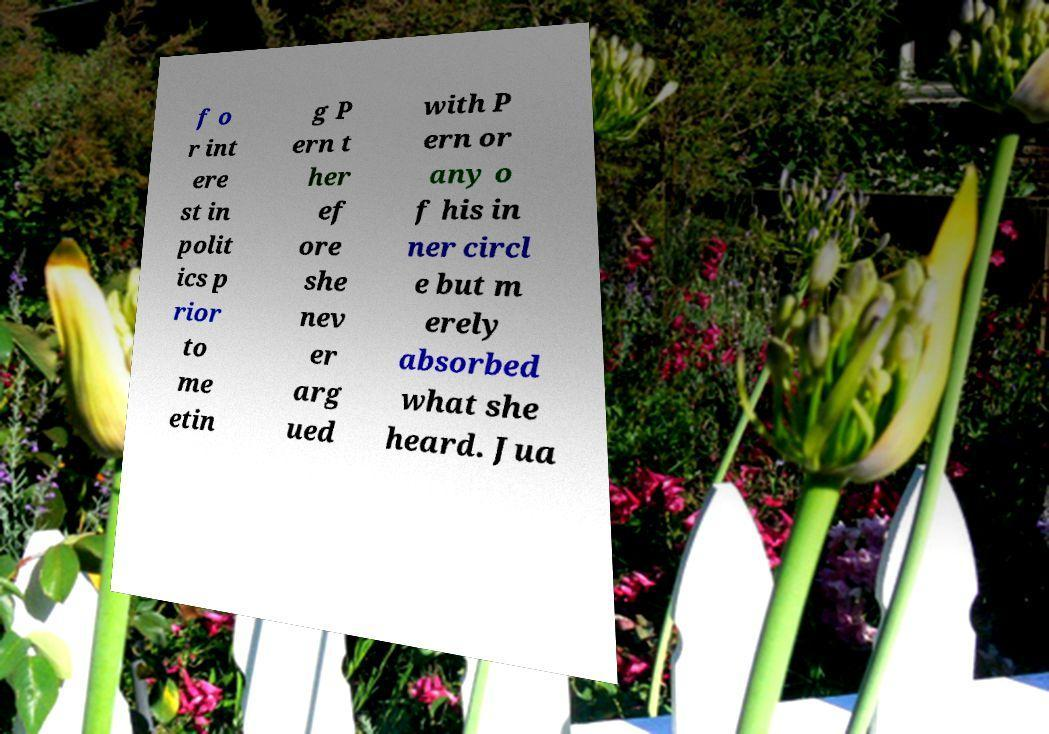Please read and relay the text visible in this image. What does it say? f o r int ere st in polit ics p rior to me etin g P ern t her ef ore she nev er arg ued with P ern or any o f his in ner circl e but m erely absorbed what she heard. Jua 